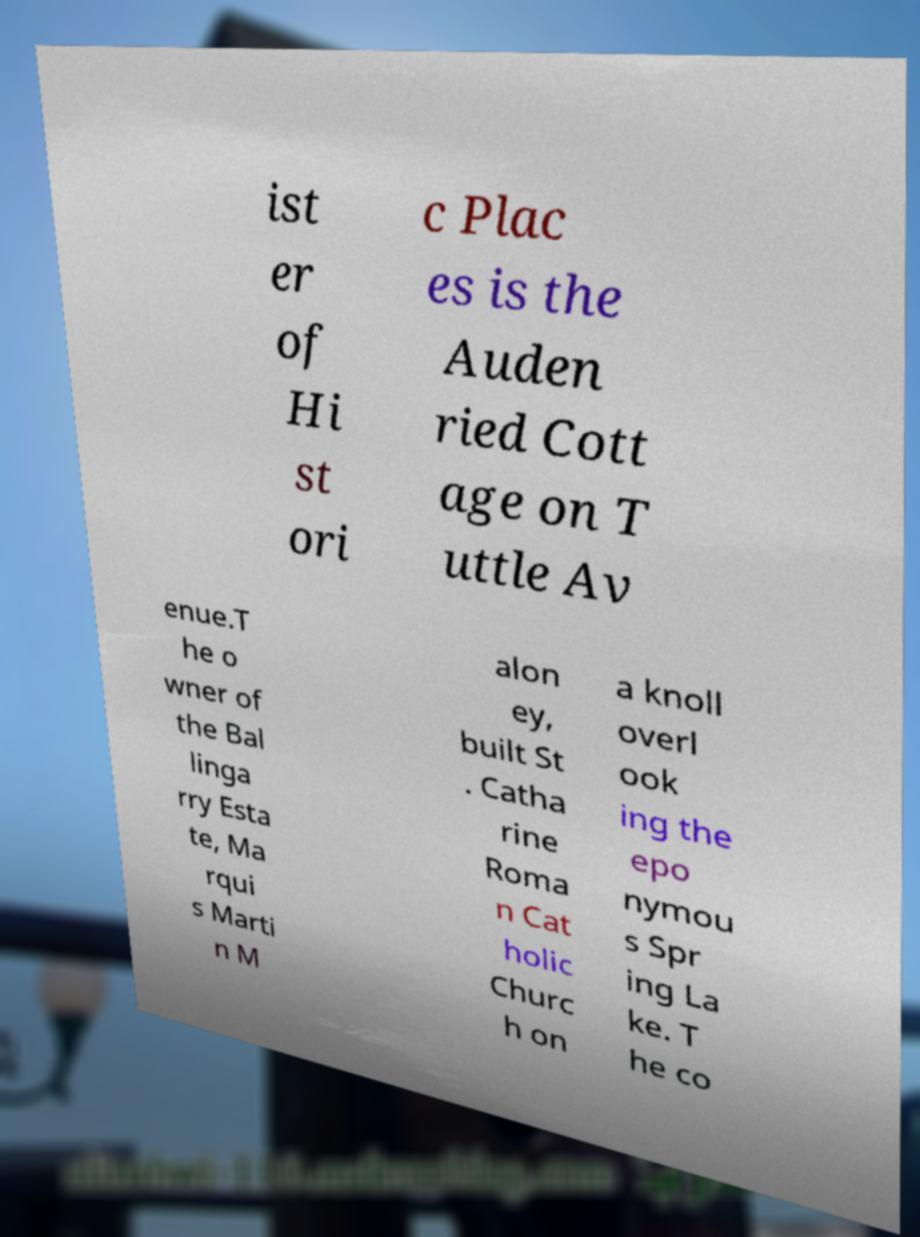What messages or text are displayed in this image? I need them in a readable, typed format. ist er of Hi st ori c Plac es is the Auden ried Cott age on T uttle Av enue.T he o wner of the Bal linga rry Esta te, Ma rqui s Marti n M alon ey, built St . Catha rine Roma n Cat holic Churc h on a knoll overl ook ing the epo nymou s Spr ing La ke. T he co 